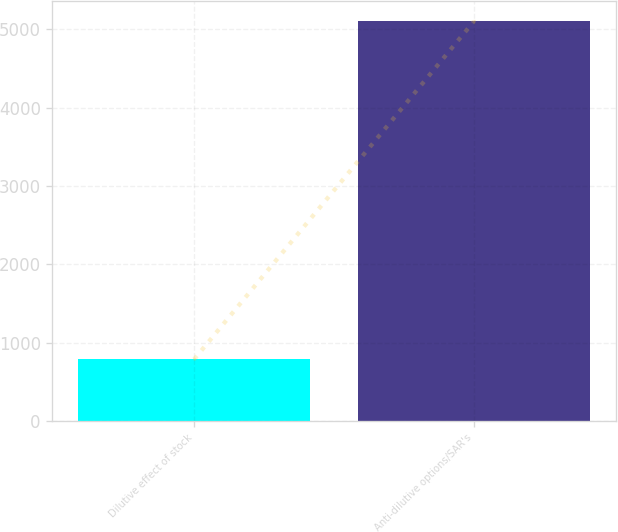Convert chart to OTSL. <chart><loc_0><loc_0><loc_500><loc_500><bar_chart><fcel>Dilutive effect of stock<fcel>Anti-dilutive options/SAR's<nl><fcel>788<fcel>5103<nl></chart> 